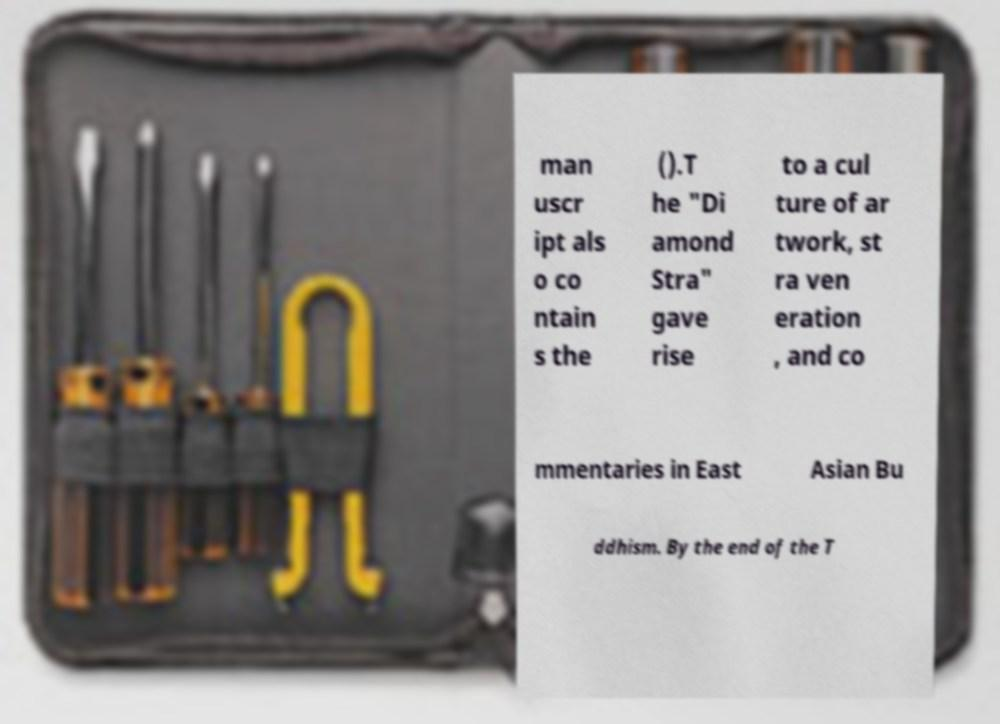Please identify and transcribe the text found in this image. man uscr ipt als o co ntain s the ().T he "Di amond Stra" gave rise to a cul ture of ar twork, st ra ven eration , and co mmentaries in East Asian Bu ddhism. By the end of the T 